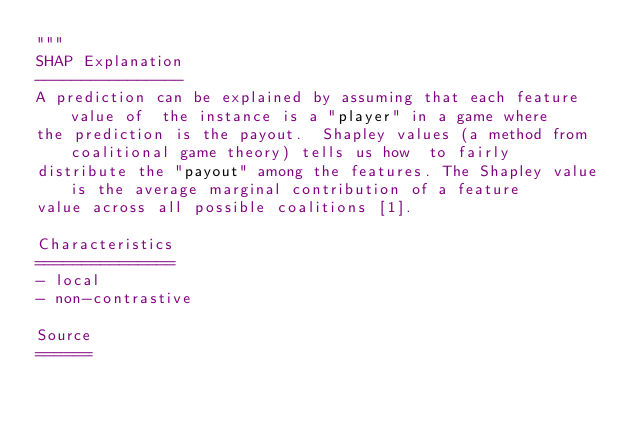<code> <loc_0><loc_0><loc_500><loc_500><_Python_>"""
SHAP Explanation
----------------
A prediction can be explained by assuming that each feature value of  the instance is a "player" in a game where 
the prediction is the payout.  Shapley values (a method from coalitional game theory) tells us how  to fairly 
distribute the "payout" among the features. The Shapley value is the average marginal contribution of a feature 
value across all possible coalitions [1].

Characteristics
===============
- local
- non-contrastive

Source
======</code> 